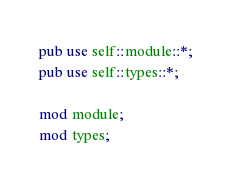<code> <loc_0><loc_0><loc_500><loc_500><_Rust_>pub use self::module::*;
pub use self::types::*;

mod module;
mod types;</code> 